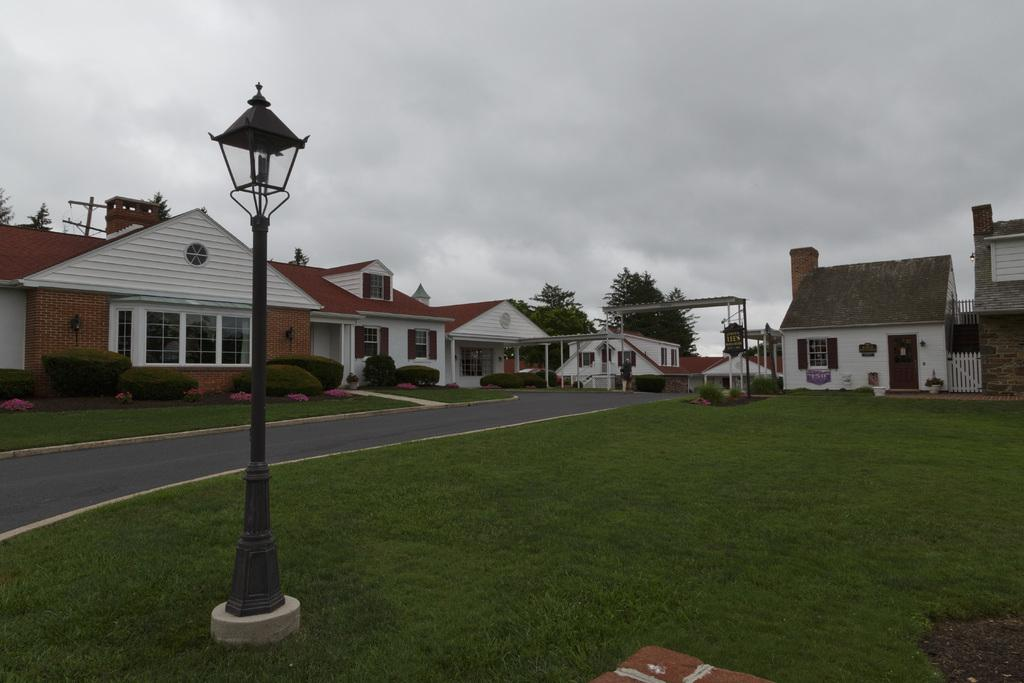What is located in the foreground of the image? There is a pole in the foreground of the image. Where is the pole situated? The pole is on the grass. What can be seen in the background of the image? There is a road, shrubs, houses, trees, and the sky visible in the background of the image. What type of baseball hobbies are being practiced in the image? There is no baseball or any hobbies related to it present in the image. What knowledge can be gained from the image about the history of the area? The image does not provide any information about the history of the area; it only shows a pole on the grass and various elements in the background. 